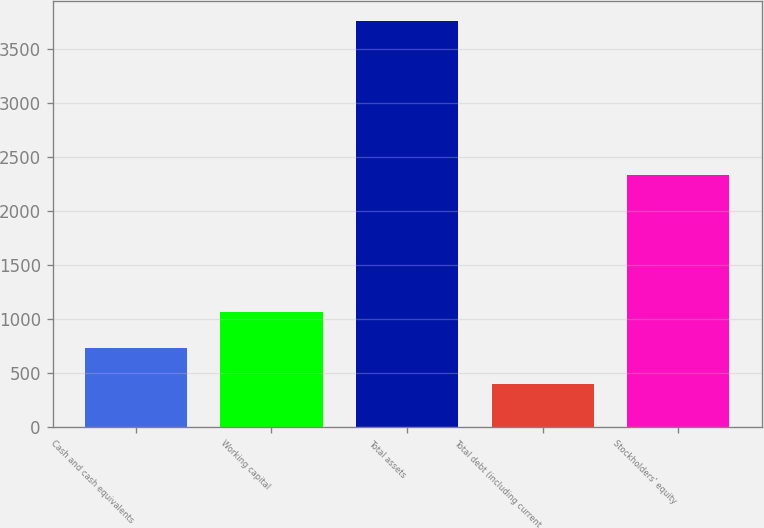Convert chart. <chart><loc_0><loc_0><loc_500><loc_500><bar_chart><fcel>Cash and cash equivalents<fcel>Working capital<fcel>Total assets<fcel>Total debt (including current<fcel>Stockholders' equity<nl><fcel>734.72<fcel>1070.64<fcel>3758<fcel>398.8<fcel>2334.9<nl></chart> 